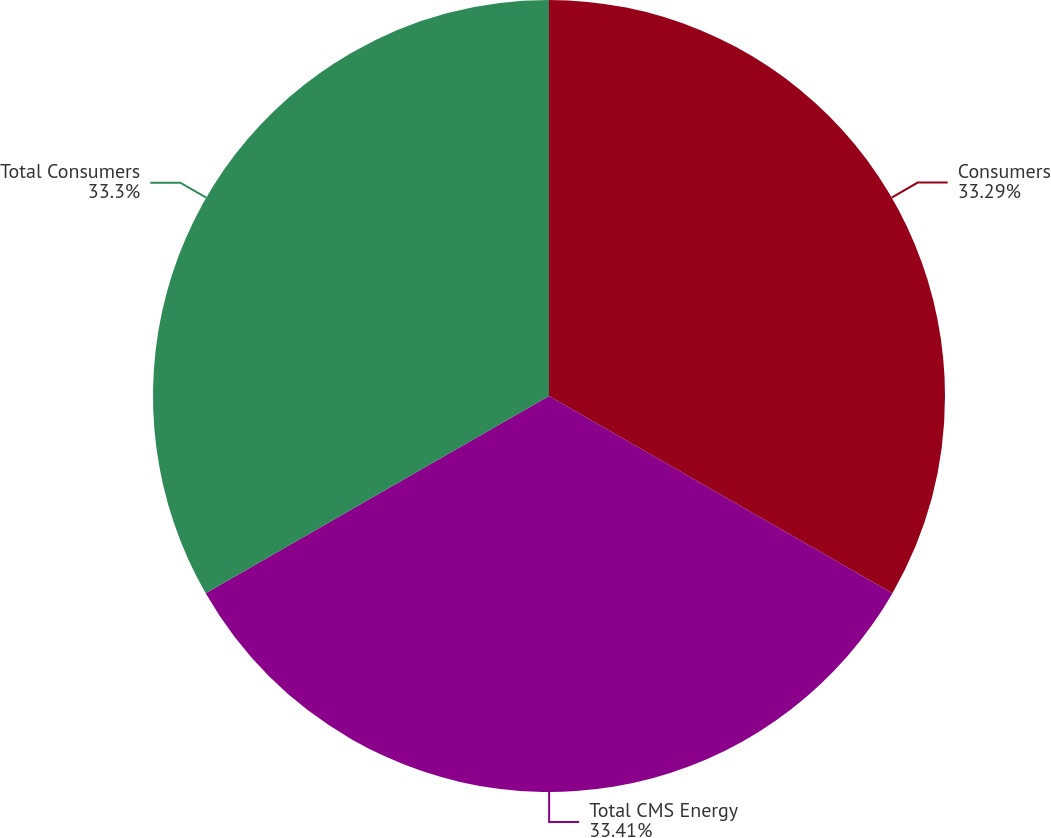Convert chart to OTSL. <chart><loc_0><loc_0><loc_500><loc_500><pie_chart><fcel>Consumers<fcel>Total CMS Energy<fcel>Total Consumers<nl><fcel>33.29%<fcel>33.4%<fcel>33.3%<nl></chart> 